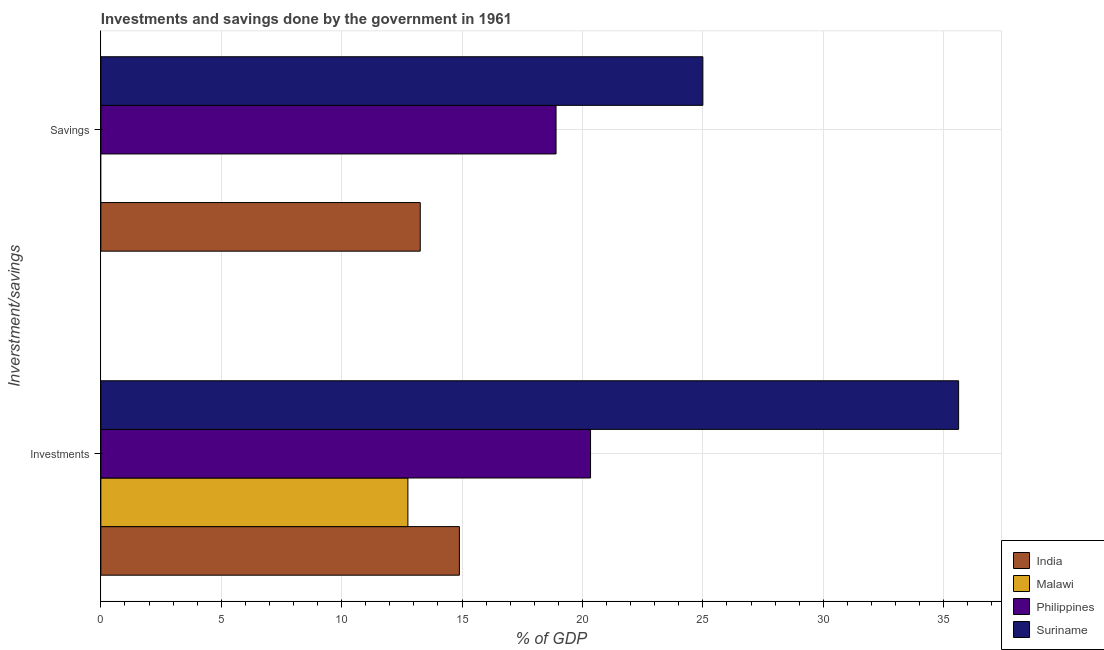How many different coloured bars are there?
Your response must be concise. 4. How many groups of bars are there?
Your answer should be very brief. 2. Are the number of bars per tick equal to the number of legend labels?
Ensure brevity in your answer.  No. Are the number of bars on each tick of the Y-axis equal?
Ensure brevity in your answer.  No. What is the label of the 1st group of bars from the top?
Ensure brevity in your answer.  Savings. What is the savings of government in Philippines?
Your answer should be compact. 18.9. Across all countries, what is the maximum savings of government?
Your answer should be very brief. 25. Across all countries, what is the minimum savings of government?
Make the answer very short. 0. In which country was the savings of government maximum?
Offer a very short reply. Suriname. What is the total savings of government in the graph?
Give a very brief answer. 57.17. What is the difference between the savings of government in Philippines and that in Suriname?
Provide a short and direct response. -6.1. What is the difference between the investments of government in Philippines and the savings of government in India?
Provide a succinct answer. 7.07. What is the average investments of government per country?
Offer a very short reply. 20.9. What is the difference between the savings of government and investments of government in India?
Your answer should be compact. -1.63. In how many countries, is the investments of government greater than 25 %?
Offer a very short reply. 1. What is the ratio of the investments of government in India to that in Philippines?
Provide a short and direct response. 0.73. What is the difference between two consecutive major ticks on the X-axis?
Keep it short and to the point. 5. Are the values on the major ticks of X-axis written in scientific E-notation?
Give a very brief answer. No. Does the graph contain any zero values?
Provide a short and direct response. Yes. How many legend labels are there?
Offer a terse response. 4. What is the title of the graph?
Your answer should be compact. Investments and savings done by the government in 1961. Does "Small states" appear as one of the legend labels in the graph?
Offer a terse response. No. What is the label or title of the X-axis?
Give a very brief answer. % of GDP. What is the label or title of the Y-axis?
Offer a very short reply. Inverstment/savings. What is the % of GDP in India in Investments?
Your answer should be very brief. 14.89. What is the % of GDP of Malawi in Investments?
Your answer should be compact. 12.75. What is the % of GDP in Philippines in Investments?
Provide a succinct answer. 20.34. What is the % of GDP of Suriname in Investments?
Provide a short and direct response. 35.62. What is the % of GDP of India in Savings?
Give a very brief answer. 13.26. What is the % of GDP of Philippines in Savings?
Give a very brief answer. 18.9. Across all Inverstment/savings, what is the maximum % of GDP of India?
Provide a short and direct response. 14.89. Across all Inverstment/savings, what is the maximum % of GDP of Malawi?
Make the answer very short. 12.75. Across all Inverstment/savings, what is the maximum % of GDP of Philippines?
Your response must be concise. 20.34. Across all Inverstment/savings, what is the maximum % of GDP in Suriname?
Provide a succinct answer. 35.62. Across all Inverstment/savings, what is the minimum % of GDP of India?
Provide a short and direct response. 13.26. Across all Inverstment/savings, what is the minimum % of GDP in Philippines?
Keep it short and to the point. 18.9. Across all Inverstment/savings, what is the minimum % of GDP of Suriname?
Keep it short and to the point. 25. What is the total % of GDP in India in the graph?
Provide a succinct answer. 28.15. What is the total % of GDP in Malawi in the graph?
Your response must be concise. 12.75. What is the total % of GDP in Philippines in the graph?
Keep it short and to the point. 39.24. What is the total % of GDP of Suriname in the graph?
Offer a terse response. 60.62. What is the difference between the % of GDP in India in Investments and that in Savings?
Your response must be concise. 1.63. What is the difference between the % of GDP of Philippines in Investments and that in Savings?
Your answer should be compact. 1.43. What is the difference between the % of GDP in Suriname in Investments and that in Savings?
Give a very brief answer. 10.62. What is the difference between the % of GDP of India in Investments and the % of GDP of Philippines in Savings?
Provide a short and direct response. -4.01. What is the difference between the % of GDP of India in Investments and the % of GDP of Suriname in Savings?
Your answer should be compact. -10.11. What is the difference between the % of GDP of Malawi in Investments and the % of GDP of Philippines in Savings?
Your answer should be very brief. -6.15. What is the difference between the % of GDP of Malawi in Investments and the % of GDP of Suriname in Savings?
Your answer should be compact. -12.25. What is the difference between the % of GDP in Philippines in Investments and the % of GDP in Suriname in Savings?
Provide a succinct answer. -4.66. What is the average % of GDP of India per Inverstment/savings?
Offer a very short reply. 14.08. What is the average % of GDP in Malawi per Inverstment/savings?
Give a very brief answer. 6.38. What is the average % of GDP in Philippines per Inverstment/savings?
Offer a very short reply. 19.62. What is the average % of GDP of Suriname per Inverstment/savings?
Provide a short and direct response. 30.31. What is the difference between the % of GDP in India and % of GDP in Malawi in Investments?
Your answer should be very brief. 2.14. What is the difference between the % of GDP of India and % of GDP of Philippines in Investments?
Provide a short and direct response. -5.45. What is the difference between the % of GDP in India and % of GDP in Suriname in Investments?
Provide a short and direct response. -20.73. What is the difference between the % of GDP of Malawi and % of GDP of Philippines in Investments?
Provide a short and direct response. -7.58. What is the difference between the % of GDP of Malawi and % of GDP of Suriname in Investments?
Ensure brevity in your answer.  -22.87. What is the difference between the % of GDP of Philippines and % of GDP of Suriname in Investments?
Your response must be concise. -15.28. What is the difference between the % of GDP of India and % of GDP of Philippines in Savings?
Make the answer very short. -5.64. What is the difference between the % of GDP in India and % of GDP in Suriname in Savings?
Provide a succinct answer. -11.74. What is the difference between the % of GDP in Philippines and % of GDP in Suriname in Savings?
Make the answer very short. -6.1. What is the ratio of the % of GDP in India in Investments to that in Savings?
Your response must be concise. 1.12. What is the ratio of the % of GDP of Philippines in Investments to that in Savings?
Your answer should be very brief. 1.08. What is the ratio of the % of GDP of Suriname in Investments to that in Savings?
Offer a terse response. 1.42. What is the difference between the highest and the second highest % of GDP of India?
Your answer should be very brief. 1.63. What is the difference between the highest and the second highest % of GDP in Philippines?
Offer a terse response. 1.43. What is the difference between the highest and the second highest % of GDP in Suriname?
Provide a short and direct response. 10.62. What is the difference between the highest and the lowest % of GDP in India?
Your answer should be compact. 1.63. What is the difference between the highest and the lowest % of GDP of Malawi?
Keep it short and to the point. 12.75. What is the difference between the highest and the lowest % of GDP in Philippines?
Provide a succinct answer. 1.43. What is the difference between the highest and the lowest % of GDP in Suriname?
Your response must be concise. 10.62. 